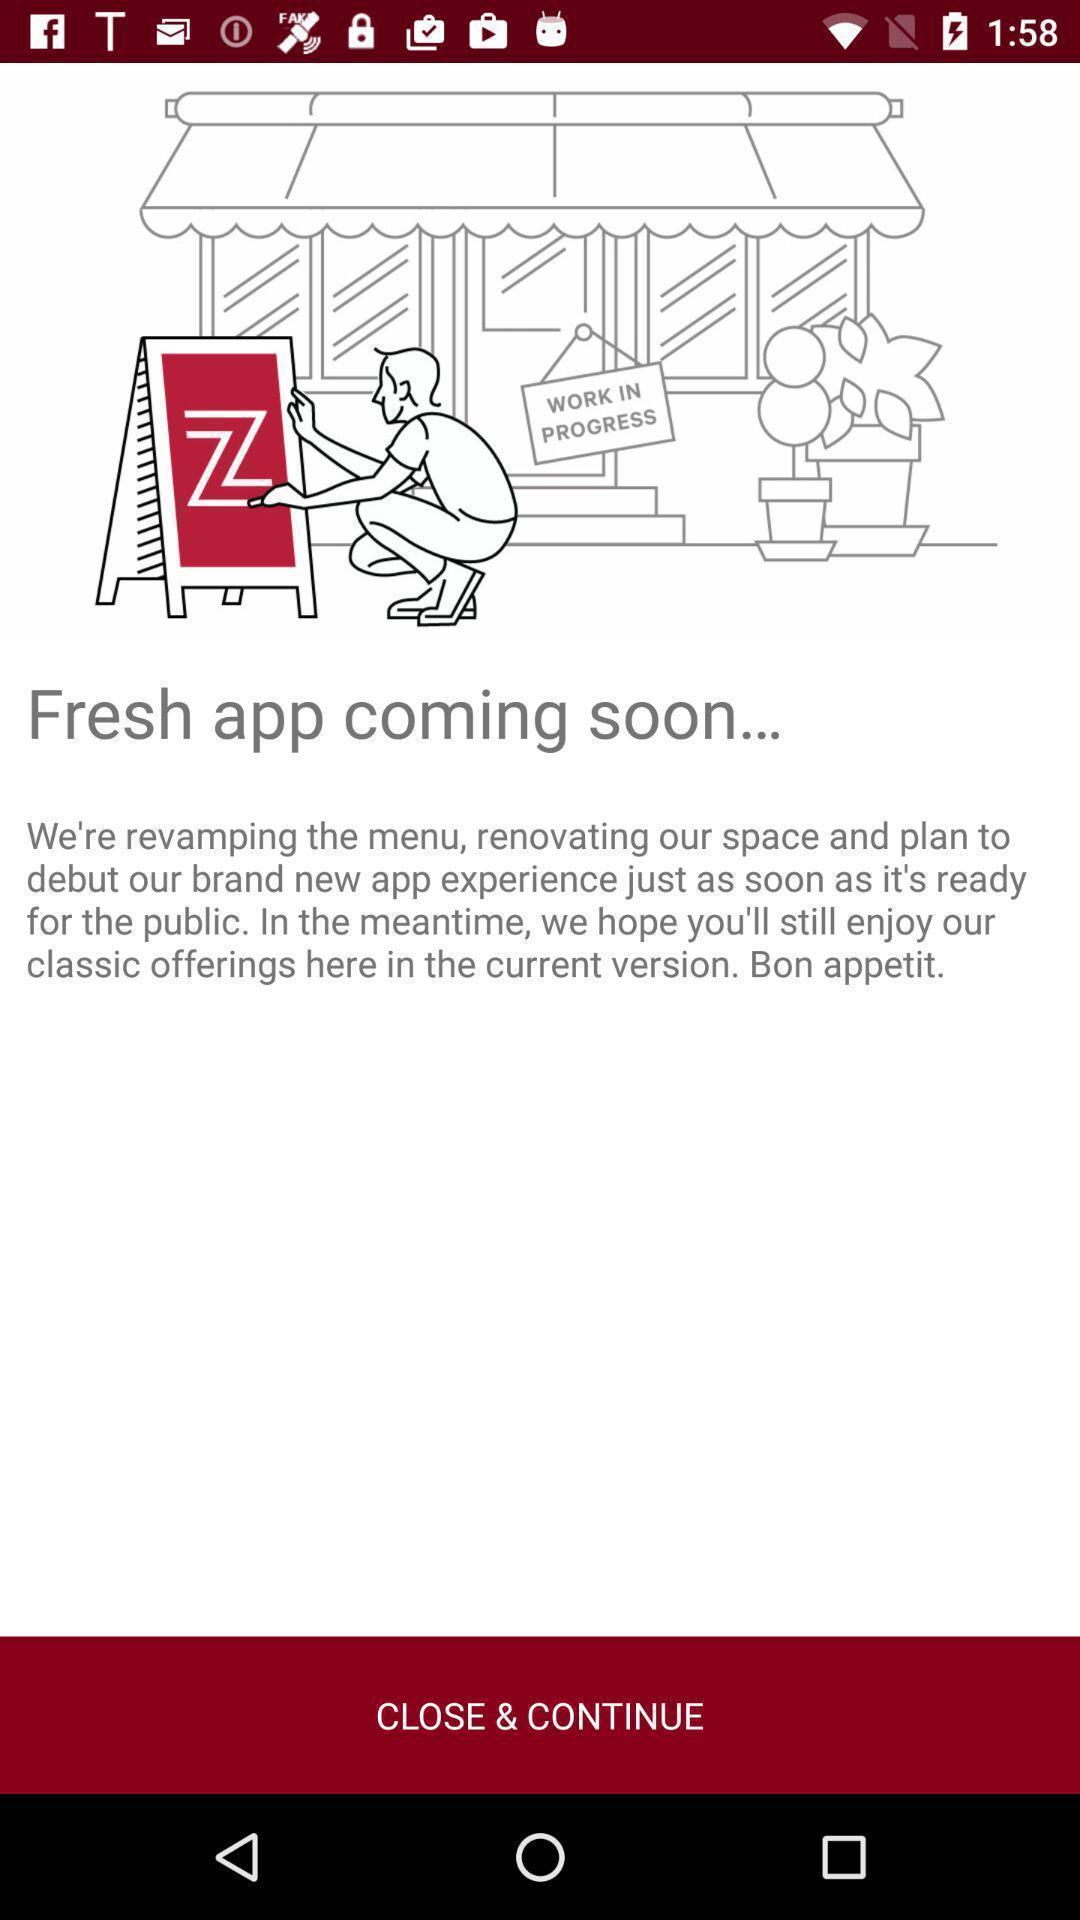Tell me about the visual elements in this screen capture. Screen displaying the coming soon notification for an app. 